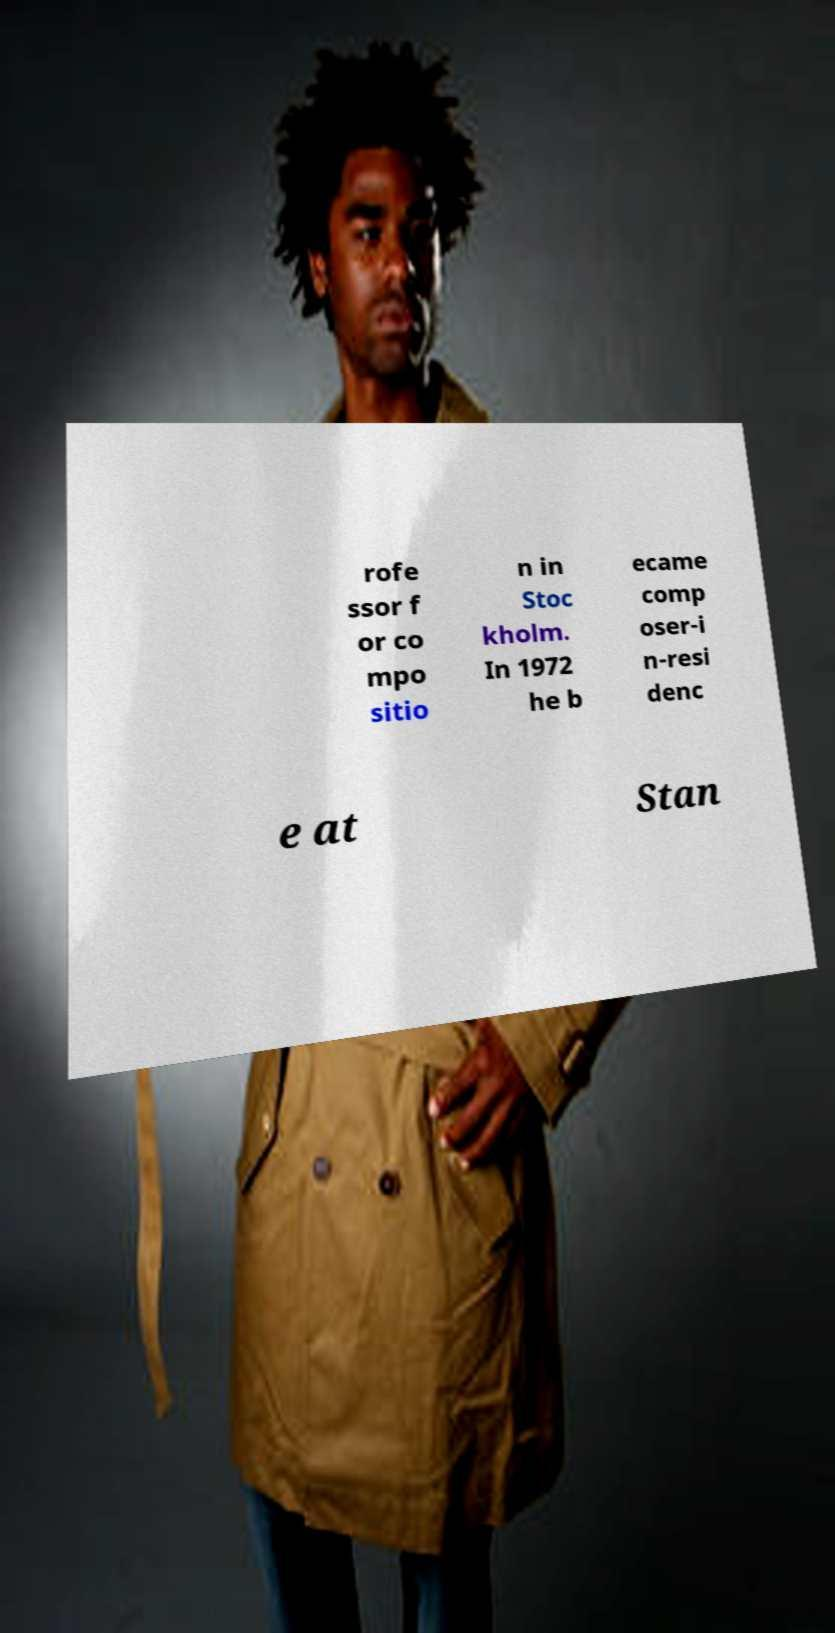Please identify and transcribe the text found in this image. rofe ssor f or co mpo sitio n in Stoc kholm. In 1972 he b ecame comp oser-i n-resi denc e at Stan 